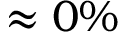<formula> <loc_0><loc_0><loc_500><loc_500>\approx 0 \%</formula> 